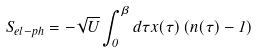<formula> <loc_0><loc_0><loc_500><loc_500>S _ { e l - p h } = - \sqrt { U } \int _ { 0 } ^ { \beta } d \tau x ( \tau ) \left ( n ( \tau ) - 1 \right )</formula> 